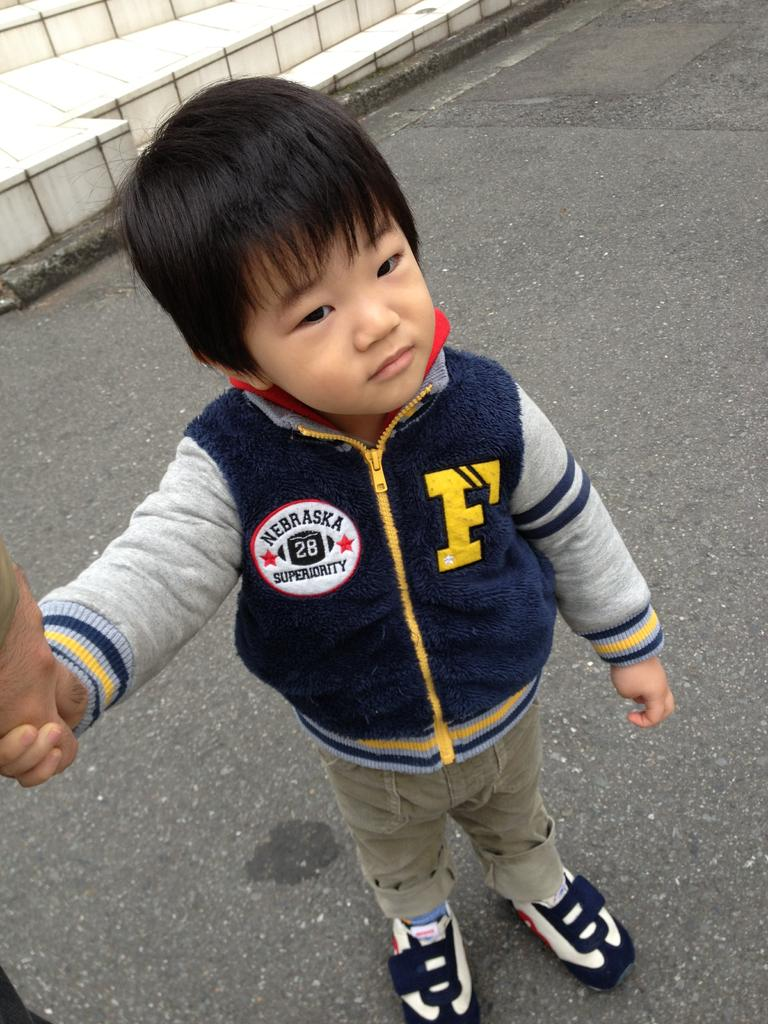Provide a one-sentence caption for the provided image. A little boy wearing a Nebraska Superiority jacket. 